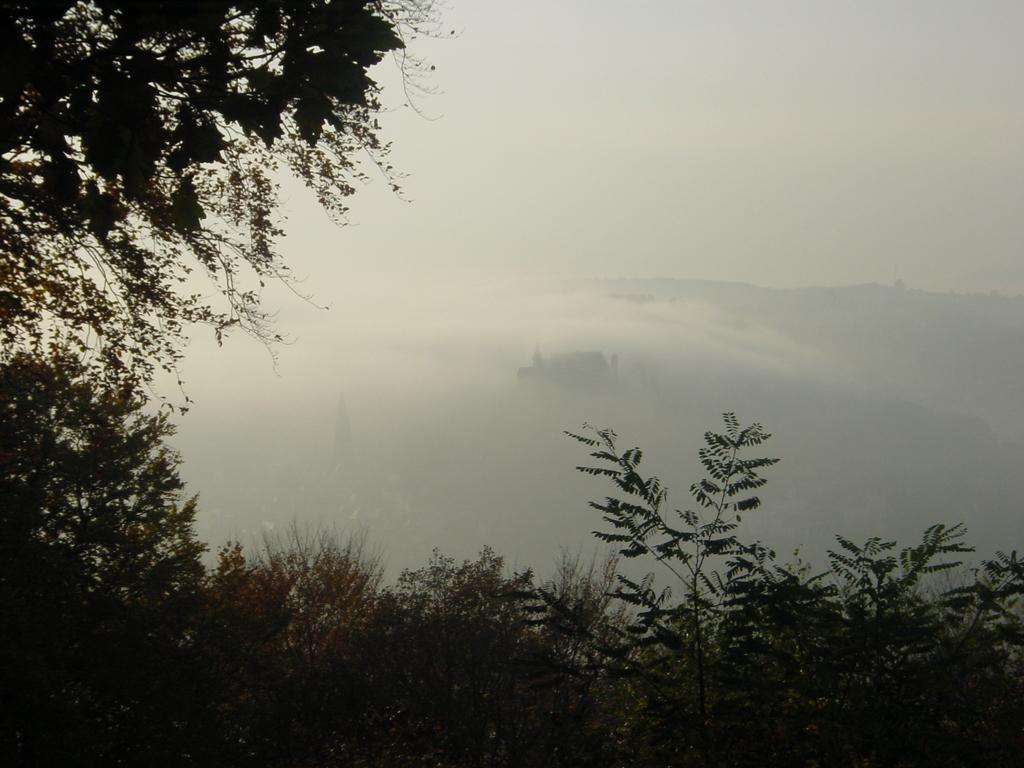What type of living organisms can be seen in the image? Plants can be seen in the image. What part of the plants is visible in the image? Leaves are visible in the image. What can be seen in the background of the image? The background of the image is unclear. What is visible in the sky in the image? The sky is visible in the image. How many pigs are attempting to climb the metal fence in the image? There are no pigs or metal fence present in the image. 